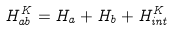Convert formula to latex. <formula><loc_0><loc_0><loc_500><loc_500>H ^ { K } _ { a b } = H _ { a } + H _ { b } + H ^ { K } _ { i n t }</formula> 